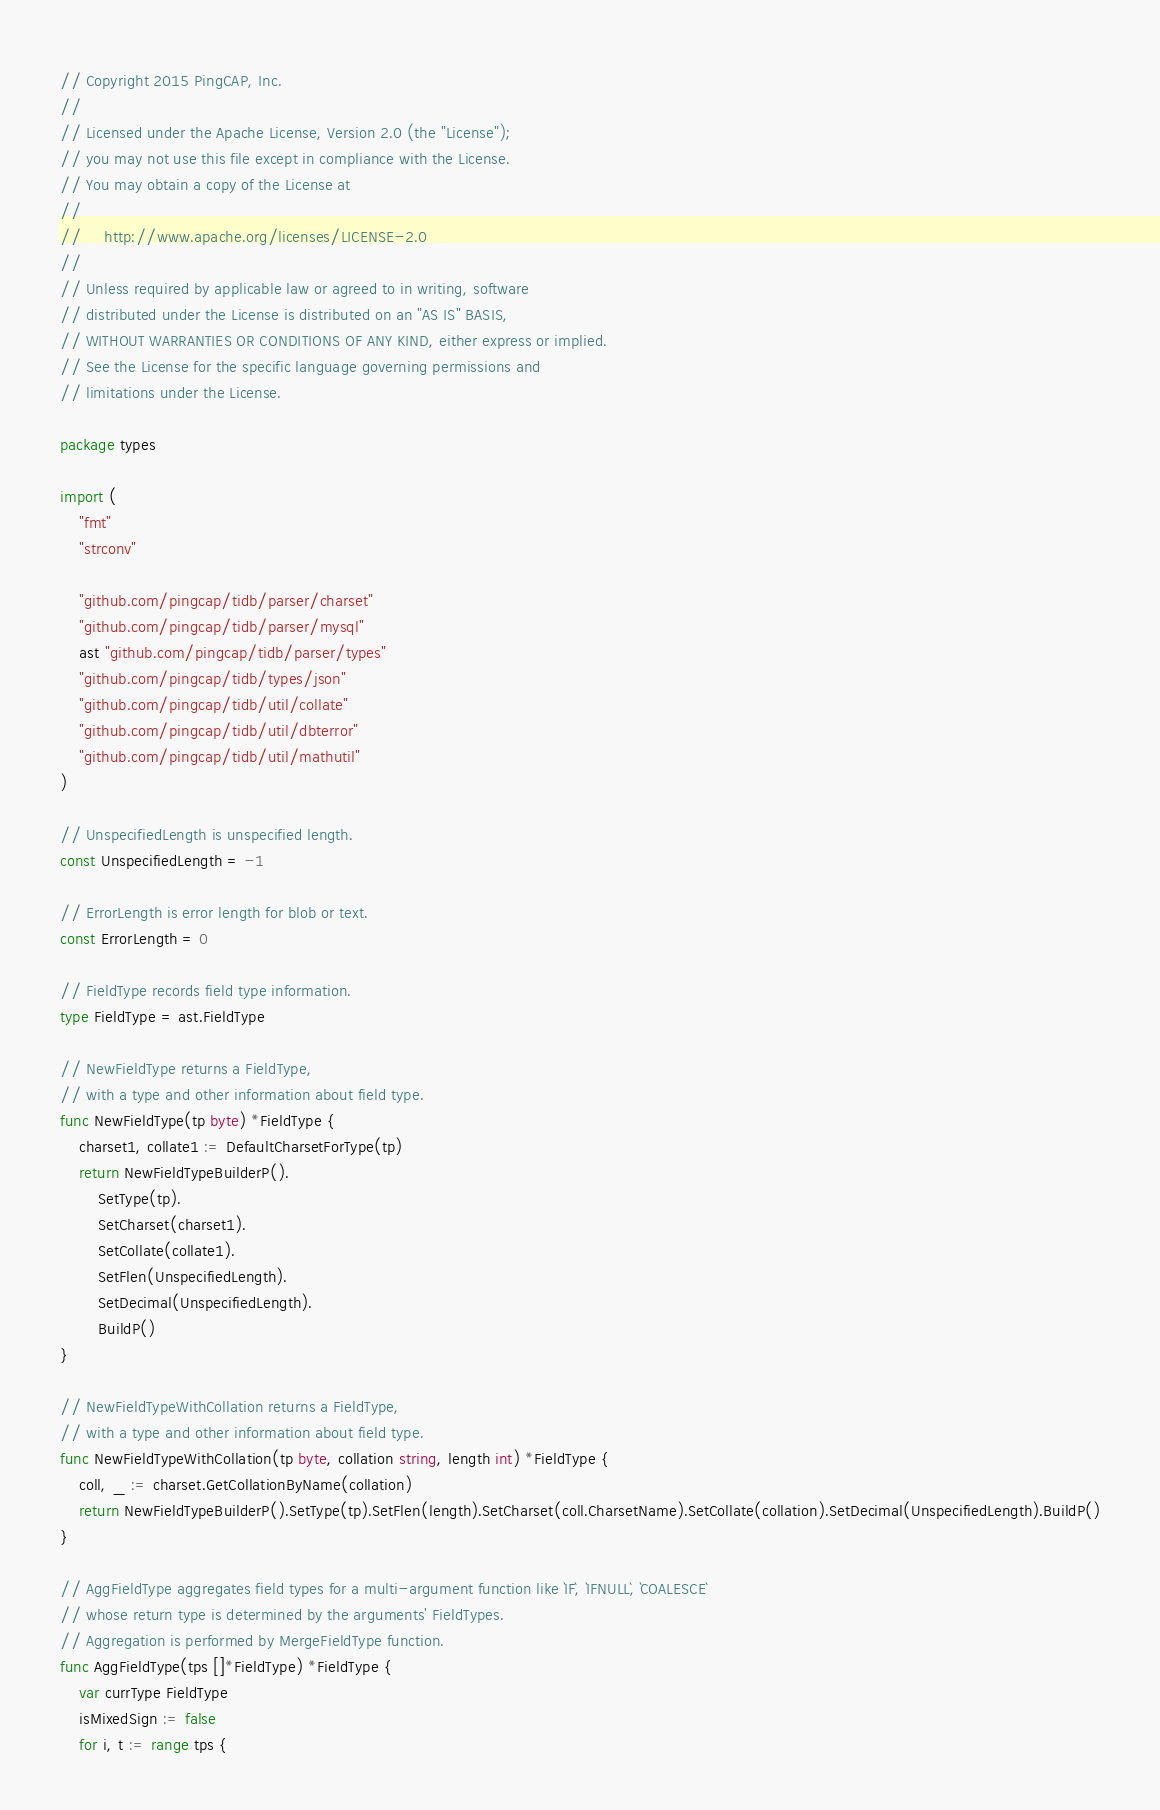Convert code to text. <code><loc_0><loc_0><loc_500><loc_500><_Go_>// Copyright 2015 PingCAP, Inc.
//
// Licensed under the Apache License, Version 2.0 (the "License");
// you may not use this file except in compliance with the License.
// You may obtain a copy of the License at
//
//     http://www.apache.org/licenses/LICENSE-2.0
//
// Unless required by applicable law or agreed to in writing, software
// distributed under the License is distributed on an "AS IS" BASIS,
// WITHOUT WARRANTIES OR CONDITIONS OF ANY KIND, either express or implied.
// See the License for the specific language governing permissions and
// limitations under the License.

package types

import (
	"fmt"
	"strconv"

	"github.com/pingcap/tidb/parser/charset"
	"github.com/pingcap/tidb/parser/mysql"
	ast "github.com/pingcap/tidb/parser/types"
	"github.com/pingcap/tidb/types/json"
	"github.com/pingcap/tidb/util/collate"
	"github.com/pingcap/tidb/util/dbterror"
	"github.com/pingcap/tidb/util/mathutil"
)

// UnspecifiedLength is unspecified length.
const UnspecifiedLength = -1

// ErrorLength is error length for blob or text.
const ErrorLength = 0

// FieldType records field type information.
type FieldType = ast.FieldType

// NewFieldType returns a FieldType,
// with a type and other information about field type.
func NewFieldType(tp byte) *FieldType {
	charset1, collate1 := DefaultCharsetForType(tp)
	return NewFieldTypeBuilderP().
		SetType(tp).
		SetCharset(charset1).
		SetCollate(collate1).
		SetFlen(UnspecifiedLength).
		SetDecimal(UnspecifiedLength).
		BuildP()
}

// NewFieldTypeWithCollation returns a FieldType,
// with a type and other information about field type.
func NewFieldTypeWithCollation(tp byte, collation string, length int) *FieldType {
	coll, _ := charset.GetCollationByName(collation)
	return NewFieldTypeBuilderP().SetType(tp).SetFlen(length).SetCharset(coll.CharsetName).SetCollate(collation).SetDecimal(UnspecifiedLength).BuildP()
}

// AggFieldType aggregates field types for a multi-argument function like `IF`, `IFNULL`, `COALESCE`
// whose return type is determined by the arguments' FieldTypes.
// Aggregation is performed by MergeFieldType function.
func AggFieldType(tps []*FieldType) *FieldType {
	var currType FieldType
	isMixedSign := false
	for i, t := range tps {</code> 